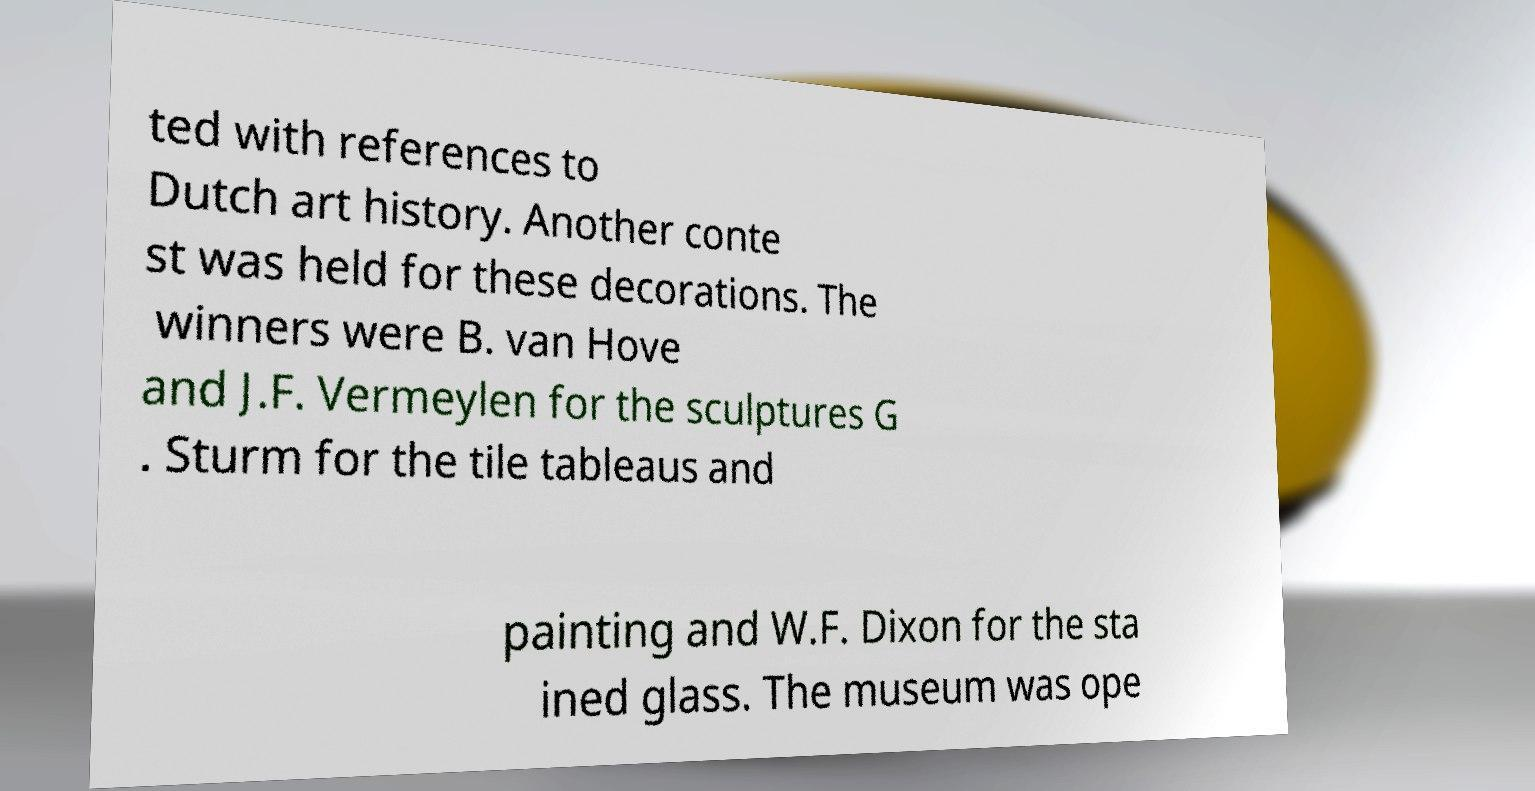Can you accurately transcribe the text from the provided image for me? ted with references to Dutch art history. Another conte st was held for these decorations. The winners were B. van Hove and J.F. Vermeylen for the sculptures G . Sturm for the tile tableaus and painting and W.F. Dixon for the sta ined glass. The museum was ope 